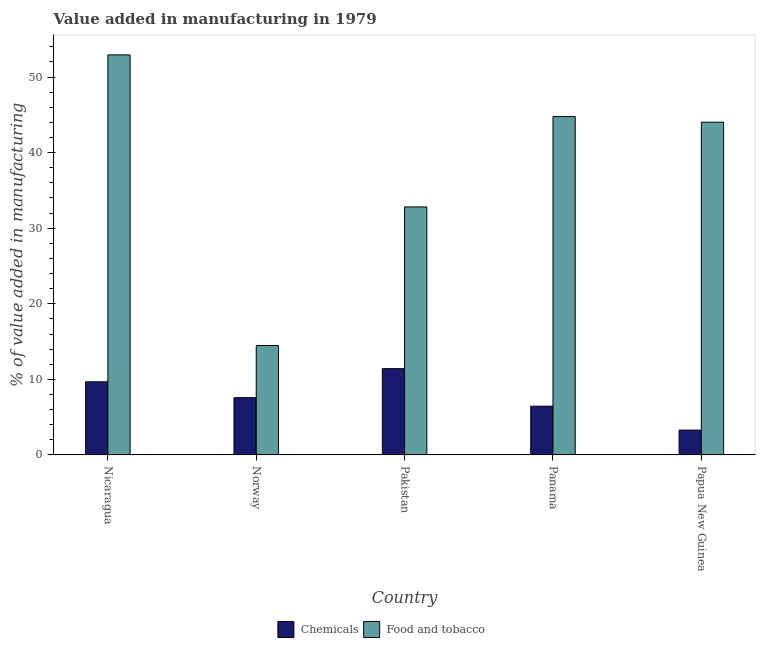How many different coloured bars are there?
Your response must be concise. 2. How many groups of bars are there?
Offer a terse response. 5. Are the number of bars per tick equal to the number of legend labels?
Offer a terse response. Yes. How many bars are there on the 3rd tick from the right?
Your response must be concise. 2. What is the label of the 4th group of bars from the left?
Make the answer very short. Panama. In how many cases, is the number of bars for a given country not equal to the number of legend labels?
Offer a very short reply. 0. What is the value added by  manufacturing chemicals in Pakistan?
Provide a short and direct response. 11.42. Across all countries, what is the maximum value added by  manufacturing chemicals?
Offer a terse response. 11.42. Across all countries, what is the minimum value added by manufacturing food and tobacco?
Keep it short and to the point. 14.48. In which country was the value added by  manufacturing chemicals maximum?
Ensure brevity in your answer.  Pakistan. What is the total value added by manufacturing food and tobacco in the graph?
Provide a short and direct response. 189.02. What is the difference between the value added by  manufacturing chemicals in Nicaragua and that in Papua New Guinea?
Offer a terse response. 6.39. What is the difference between the value added by  manufacturing chemicals in Norway and the value added by manufacturing food and tobacco in Pakistan?
Make the answer very short. -25.24. What is the average value added by manufacturing food and tobacco per country?
Offer a terse response. 37.8. What is the difference between the value added by manufacturing food and tobacco and value added by  manufacturing chemicals in Panama?
Your answer should be compact. 38.32. What is the ratio of the value added by  manufacturing chemicals in Panama to that in Papua New Guinea?
Provide a succinct answer. 1.96. Is the value added by manufacturing food and tobacco in Pakistan less than that in Panama?
Offer a very short reply. Yes. Is the difference between the value added by manufacturing food and tobacco in Norway and Pakistan greater than the difference between the value added by  manufacturing chemicals in Norway and Pakistan?
Ensure brevity in your answer.  No. What is the difference between the highest and the second highest value added by  manufacturing chemicals?
Offer a terse response. 1.74. What is the difference between the highest and the lowest value added by manufacturing food and tobacco?
Provide a succinct answer. 38.46. In how many countries, is the value added by manufacturing food and tobacco greater than the average value added by manufacturing food and tobacco taken over all countries?
Your response must be concise. 3. Is the sum of the value added by  manufacturing chemicals in Nicaragua and Papua New Guinea greater than the maximum value added by manufacturing food and tobacco across all countries?
Offer a very short reply. No. What does the 2nd bar from the left in Norway represents?
Ensure brevity in your answer.  Food and tobacco. What does the 1st bar from the right in Norway represents?
Ensure brevity in your answer.  Food and tobacco. How many bars are there?
Provide a short and direct response. 10. Does the graph contain grids?
Ensure brevity in your answer.  No. How many legend labels are there?
Ensure brevity in your answer.  2. What is the title of the graph?
Offer a terse response. Value added in manufacturing in 1979. What is the label or title of the Y-axis?
Provide a short and direct response. % of value added in manufacturing. What is the % of value added in manufacturing of Chemicals in Nicaragua?
Give a very brief answer. 9.68. What is the % of value added in manufacturing in Food and tobacco in Nicaragua?
Offer a terse response. 52.93. What is the % of value added in manufacturing in Chemicals in Norway?
Make the answer very short. 7.57. What is the % of value added in manufacturing of Food and tobacco in Norway?
Your answer should be very brief. 14.48. What is the % of value added in manufacturing of Chemicals in Pakistan?
Make the answer very short. 11.42. What is the % of value added in manufacturing of Food and tobacco in Pakistan?
Give a very brief answer. 32.82. What is the % of value added in manufacturing of Chemicals in Panama?
Offer a terse response. 6.45. What is the % of value added in manufacturing of Food and tobacco in Panama?
Provide a short and direct response. 44.77. What is the % of value added in manufacturing of Chemicals in Papua New Guinea?
Your answer should be very brief. 3.29. What is the % of value added in manufacturing of Food and tobacco in Papua New Guinea?
Offer a very short reply. 44.03. Across all countries, what is the maximum % of value added in manufacturing of Chemicals?
Keep it short and to the point. 11.42. Across all countries, what is the maximum % of value added in manufacturing in Food and tobacco?
Make the answer very short. 52.93. Across all countries, what is the minimum % of value added in manufacturing of Chemicals?
Provide a short and direct response. 3.29. Across all countries, what is the minimum % of value added in manufacturing of Food and tobacco?
Make the answer very short. 14.48. What is the total % of value added in manufacturing of Chemicals in the graph?
Keep it short and to the point. 38.4. What is the total % of value added in manufacturing in Food and tobacco in the graph?
Your response must be concise. 189.02. What is the difference between the % of value added in manufacturing in Chemicals in Nicaragua and that in Norway?
Your response must be concise. 2.1. What is the difference between the % of value added in manufacturing in Food and tobacco in Nicaragua and that in Norway?
Give a very brief answer. 38.46. What is the difference between the % of value added in manufacturing of Chemicals in Nicaragua and that in Pakistan?
Your answer should be compact. -1.74. What is the difference between the % of value added in manufacturing in Food and tobacco in Nicaragua and that in Pakistan?
Keep it short and to the point. 20.12. What is the difference between the % of value added in manufacturing of Chemicals in Nicaragua and that in Panama?
Give a very brief answer. 3.23. What is the difference between the % of value added in manufacturing of Food and tobacco in Nicaragua and that in Panama?
Your answer should be very brief. 8.17. What is the difference between the % of value added in manufacturing of Chemicals in Nicaragua and that in Papua New Guinea?
Offer a terse response. 6.39. What is the difference between the % of value added in manufacturing in Food and tobacco in Nicaragua and that in Papua New Guinea?
Offer a very short reply. 8.9. What is the difference between the % of value added in manufacturing in Chemicals in Norway and that in Pakistan?
Your answer should be compact. -3.84. What is the difference between the % of value added in manufacturing in Food and tobacco in Norway and that in Pakistan?
Make the answer very short. -18.34. What is the difference between the % of value added in manufacturing of Chemicals in Norway and that in Panama?
Ensure brevity in your answer.  1.13. What is the difference between the % of value added in manufacturing of Food and tobacco in Norway and that in Panama?
Ensure brevity in your answer.  -30.29. What is the difference between the % of value added in manufacturing of Chemicals in Norway and that in Papua New Guinea?
Provide a succinct answer. 4.29. What is the difference between the % of value added in manufacturing in Food and tobacco in Norway and that in Papua New Guinea?
Offer a very short reply. -29.55. What is the difference between the % of value added in manufacturing in Chemicals in Pakistan and that in Panama?
Provide a short and direct response. 4.97. What is the difference between the % of value added in manufacturing of Food and tobacco in Pakistan and that in Panama?
Your answer should be compact. -11.95. What is the difference between the % of value added in manufacturing in Chemicals in Pakistan and that in Papua New Guinea?
Give a very brief answer. 8.13. What is the difference between the % of value added in manufacturing of Food and tobacco in Pakistan and that in Papua New Guinea?
Keep it short and to the point. -11.21. What is the difference between the % of value added in manufacturing of Chemicals in Panama and that in Papua New Guinea?
Ensure brevity in your answer.  3.16. What is the difference between the % of value added in manufacturing of Food and tobacco in Panama and that in Papua New Guinea?
Make the answer very short. 0.74. What is the difference between the % of value added in manufacturing in Chemicals in Nicaragua and the % of value added in manufacturing in Food and tobacco in Norway?
Your answer should be very brief. -4.8. What is the difference between the % of value added in manufacturing in Chemicals in Nicaragua and the % of value added in manufacturing in Food and tobacco in Pakistan?
Offer a terse response. -23.14. What is the difference between the % of value added in manufacturing of Chemicals in Nicaragua and the % of value added in manufacturing of Food and tobacco in Panama?
Make the answer very short. -35.09. What is the difference between the % of value added in manufacturing of Chemicals in Nicaragua and the % of value added in manufacturing of Food and tobacco in Papua New Guinea?
Your answer should be very brief. -34.35. What is the difference between the % of value added in manufacturing in Chemicals in Norway and the % of value added in manufacturing in Food and tobacco in Pakistan?
Provide a short and direct response. -25.24. What is the difference between the % of value added in manufacturing of Chemicals in Norway and the % of value added in manufacturing of Food and tobacco in Panama?
Make the answer very short. -37.19. What is the difference between the % of value added in manufacturing in Chemicals in Norway and the % of value added in manufacturing in Food and tobacco in Papua New Guinea?
Ensure brevity in your answer.  -36.45. What is the difference between the % of value added in manufacturing of Chemicals in Pakistan and the % of value added in manufacturing of Food and tobacco in Panama?
Offer a very short reply. -33.35. What is the difference between the % of value added in manufacturing in Chemicals in Pakistan and the % of value added in manufacturing in Food and tobacco in Papua New Guinea?
Your response must be concise. -32.61. What is the difference between the % of value added in manufacturing in Chemicals in Panama and the % of value added in manufacturing in Food and tobacco in Papua New Guinea?
Your response must be concise. -37.58. What is the average % of value added in manufacturing in Chemicals per country?
Give a very brief answer. 7.68. What is the average % of value added in manufacturing in Food and tobacco per country?
Keep it short and to the point. 37.8. What is the difference between the % of value added in manufacturing of Chemicals and % of value added in manufacturing of Food and tobacco in Nicaragua?
Provide a short and direct response. -43.26. What is the difference between the % of value added in manufacturing of Chemicals and % of value added in manufacturing of Food and tobacco in Norway?
Provide a short and direct response. -6.9. What is the difference between the % of value added in manufacturing in Chemicals and % of value added in manufacturing in Food and tobacco in Pakistan?
Give a very brief answer. -21.4. What is the difference between the % of value added in manufacturing of Chemicals and % of value added in manufacturing of Food and tobacco in Panama?
Provide a short and direct response. -38.32. What is the difference between the % of value added in manufacturing of Chemicals and % of value added in manufacturing of Food and tobacco in Papua New Guinea?
Provide a short and direct response. -40.74. What is the ratio of the % of value added in manufacturing in Chemicals in Nicaragua to that in Norway?
Provide a short and direct response. 1.28. What is the ratio of the % of value added in manufacturing in Food and tobacco in Nicaragua to that in Norway?
Ensure brevity in your answer.  3.66. What is the ratio of the % of value added in manufacturing in Chemicals in Nicaragua to that in Pakistan?
Keep it short and to the point. 0.85. What is the ratio of the % of value added in manufacturing in Food and tobacco in Nicaragua to that in Pakistan?
Offer a terse response. 1.61. What is the ratio of the % of value added in manufacturing of Chemicals in Nicaragua to that in Panama?
Ensure brevity in your answer.  1.5. What is the ratio of the % of value added in manufacturing of Food and tobacco in Nicaragua to that in Panama?
Keep it short and to the point. 1.18. What is the ratio of the % of value added in manufacturing of Chemicals in Nicaragua to that in Papua New Guinea?
Keep it short and to the point. 2.94. What is the ratio of the % of value added in manufacturing of Food and tobacco in Nicaragua to that in Papua New Guinea?
Your response must be concise. 1.2. What is the ratio of the % of value added in manufacturing of Chemicals in Norway to that in Pakistan?
Make the answer very short. 0.66. What is the ratio of the % of value added in manufacturing in Food and tobacco in Norway to that in Pakistan?
Give a very brief answer. 0.44. What is the ratio of the % of value added in manufacturing of Chemicals in Norway to that in Panama?
Make the answer very short. 1.17. What is the ratio of the % of value added in manufacturing in Food and tobacco in Norway to that in Panama?
Your response must be concise. 0.32. What is the ratio of the % of value added in manufacturing in Chemicals in Norway to that in Papua New Guinea?
Ensure brevity in your answer.  2.31. What is the ratio of the % of value added in manufacturing in Food and tobacco in Norway to that in Papua New Guinea?
Your answer should be compact. 0.33. What is the ratio of the % of value added in manufacturing in Chemicals in Pakistan to that in Panama?
Your answer should be compact. 1.77. What is the ratio of the % of value added in manufacturing in Food and tobacco in Pakistan to that in Panama?
Provide a succinct answer. 0.73. What is the ratio of the % of value added in manufacturing of Chemicals in Pakistan to that in Papua New Guinea?
Your answer should be very brief. 3.47. What is the ratio of the % of value added in manufacturing of Food and tobacco in Pakistan to that in Papua New Guinea?
Your answer should be very brief. 0.75. What is the ratio of the % of value added in manufacturing of Chemicals in Panama to that in Papua New Guinea?
Offer a very short reply. 1.96. What is the ratio of the % of value added in manufacturing in Food and tobacco in Panama to that in Papua New Guinea?
Your answer should be very brief. 1.02. What is the difference between the highest and the second highest % of value added in manufacturing of Chemicals?
Keep it short and to the point. 1.74. What is the difference between the highest and the second highest % of value added in manufacturing of Food and tobacco?
Offer a very short reply. 8.17. What is the difference between the highest and the lowest % of value added in manufacturing of Chemicals?
Offer a very short reply. 8.13. What is the difference between the highest and the lowest % of value added in manufacturing in Food and tobacco?
Provide a succinct answer. 38.46. 